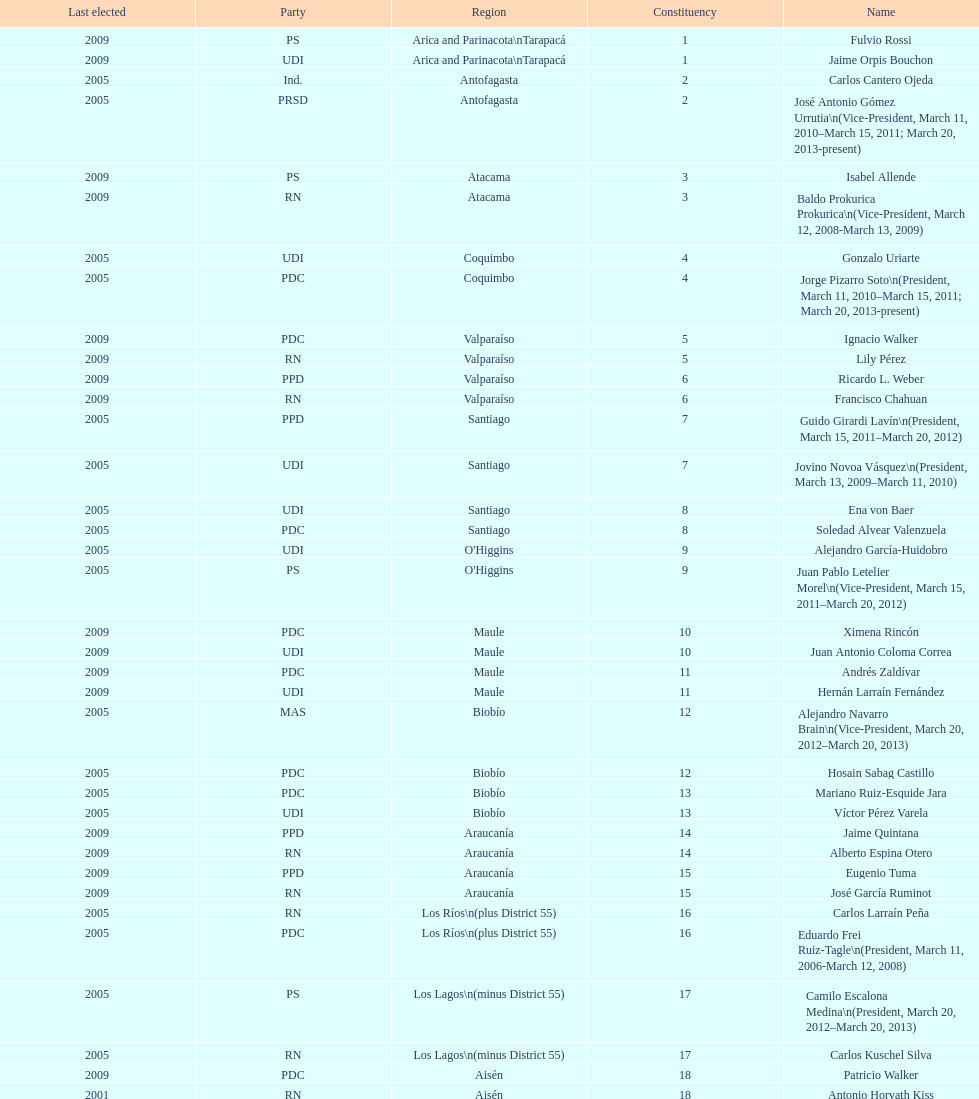Who was not last elected in either 2005 or 2009? Antonio Horvath Kiss. 